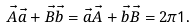<formula> <loc_0><loc_0><loc_500><loc_500>\vec { A } \vec { a } + \vec { B } \vec { b } = \vec { a } \vec { A } + \vec { b } \vec { B } = 2 \pi { \mathsf 1 } .</formula> 